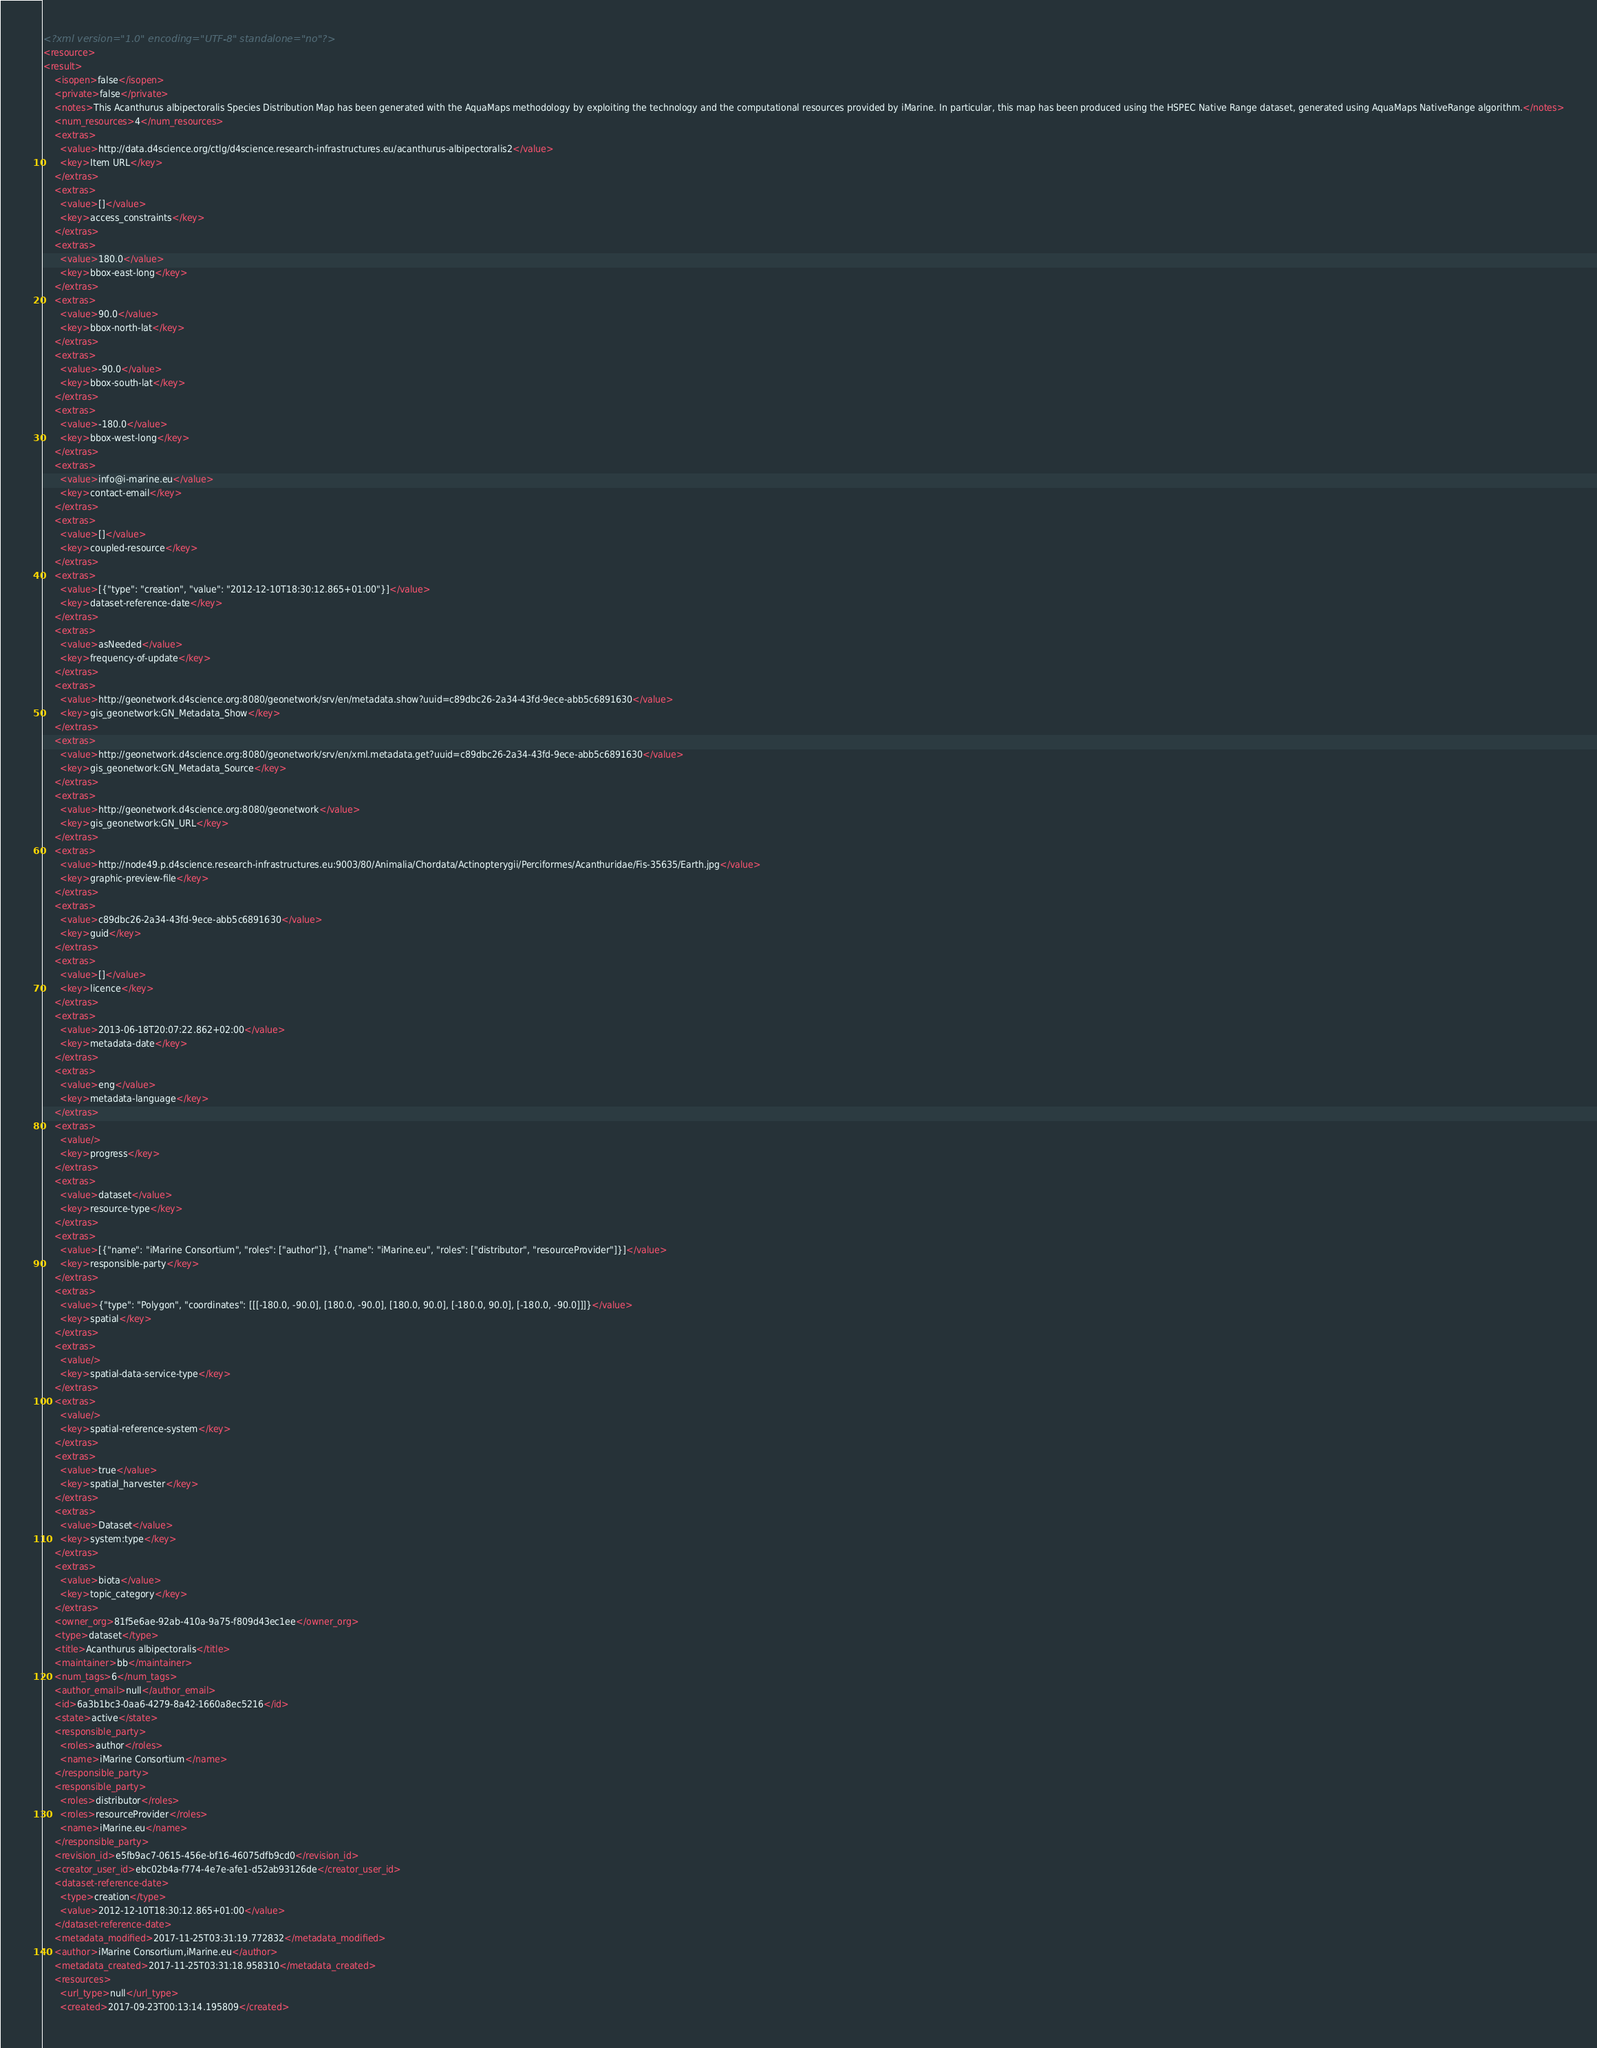<code> <loc_0><loc_0><loc_500><loc_500><_XML_><?xml version="1.0" encoding="UTF-8" standalone="no"?>
<resource>
<result>
    <isopen>false</isopen>
    <private>false</private>
    <notes>This Acanthurus albipectoralis Species Distribution Map has been generated with the AquaMaps methodology by exploiting the technology and the computational resources provided by iMarine. In particular, this map has been produced using the HSPEC Native Range dataset, generated using AquaMaps NativeRange algorithm.</notes>
    <num_resources>4</num_resources>
    <extras>
      <value>http://data.d4science.org/ctlg/d4science.research-infrastructures.eu/acanthurus-albipectoralis2</value>
      <key>Item URL</key>
    </extras>
    <extras>
      <value>[]</value>
      <key>access_constraints</key>
    </extras>
    <extras>
      <value>180.0</value>
      <key>bbox-east-long</key>
    </extras>
    <extras>
      <value>90.0</value>
      <key>bbox-north-lat</key>
    </extras>
    <extras>
      <value>-90.0</value>
      <key>bbox-south-lat</key>
    </extras>
    <extras>
      <value>-180.0</value>
      <key>bbox-west-long</key>
    </extras>
    <extras>
      <value>info@i-marine.eu</value>
      <key>contact-email</key>
    </extras>
    <extras>
      <value>[]</value>
      <key>coupled-resource</key>
    </extras>
    <extras>
      <value>[{"type": "creation", "value": "2012-12-10T18:30:12.865+01:00"}]</value>
      <key>dataset-reference-date</key>
    </extras>
    <extras>
      <value>asNeeded</value>
      <key>frequency-of-update</key>
    </extras>
    <extras>
      <value>http://geonetwork.d4science.org:8080/geonetwork/srv/en/metadata.show?uuid=c89dbc26-2a34-43fd-9ece-abb5c6891630</value>
      <key>gis_geonetwork:GN_Metadata_Show</key>
    </extras>
    <extras>
      <value>http://geonetwork.d4science.org:8080/geonetwork/srv/en/xml.metadata.get?uuid=c89dbc26-2a34-43fd-9ece-abb5c6891630</value>
      <key>gis_geonetwork:GN_Metadata_Source</key>
    </extras>
    <extras>
      <value>http://geonetwork.d4science.org:8080/geonetwork</value>
      <key>gis_geonetwork:GN_URL</key>
    </extras>
    <extras>
      <value>http://node49.p.d4science.research-infrastructures.eu:9003/80/Animalia/Chordata/Actinopterygii/Perciformes/Acanthuridae/Fis-35635/Earth.jpg</value>
      <key>graphic-preview-file</key>
    </extras>
    <extras>
      <value>c89dbc26-2a34-43fd-9ece-abb5c6891630</value>
      <key>guid</key>
    </extras>
    <extras>
      <value>[]</value>
      <key>licence</key>
    </extras>
    <extras>
      <value>2013-06-18T20:07:22.862+02:00</value>
      <key>metadata-date</key>
    </extras>
    <extras>
      <value>eng</value>
      <key>metadata-language</key>
    </extras>
    <extras>
      <value/>
      <key>progress</key>
    </extras>
    <extras>
      <value>dataset</value>
      <key>resource-type</key>
    </extras>
    <extras>
      <value>[{"name": "iMarine Consortium", "roles": ["author"]}, {"name": "iMarine.eu", "roles": ["distributor", "resourceProvider"]}]</value>
      <key>responsible-party</key>
    </extras>
    <extras>
      <value>{"type": "Polygon", "coordinates": [[[-180.0, -90.0], [180.0, -90.0], [180.0, 90.0], [-180.0, 90.0], [-180.0, -90.0]]]}</value>
      <key>spatial</key>
    </extras>
    <extras>
      <value/>
      <key>spatial-data-service-type</key>
    </extras>
    <extras>
      <value/>
      <key>spatial-reference-system</key>
    </extras>
    <extras>
      <value>true</value>
      <key>spatial_harvester</key>
    </extras>
    <extras>
      <value>Dataset</value>
      <key>system:type</key>
    </extras>
    <extras>
      <value>biota</value>
      <key>topic_category</key>
    </extras>
    <owner_org>81f5e6ae-92ab-410a-9a75-f809d43ec1ee</owner_org>
    <type>dataset</type>
    <title>Acanthurus albipectoralis</title>
    <maintainer>bb</maintainer>
    <num_tags>6</num_tags>
    <author_email>null</author_email>
    <id>6a3b1bc3-0aa6-4279-8a42-1660a8ec5216</id>
    <state>active</state>
    <responsible_party>
      <roles>author</roles>
      <name>iMarine Consortium</name>
    </responsible_party>
    <responsible_party>
      <roles>distributor</roles>
      <roles>resourceProvider</roles>
      <name>iMarine.eu</name>
    </responsible_party>
    <revision_id>e5fb9ac7-0615-456e-bf16-46075dfb9cd0</revision_id>
    <creator_user_id>ebc02b4a-f774-4e7e-afe1-d52ab93126de</creator_user_id>
    <dataset-reference-date>
      <type>creation</type>
      <value>2012-12-10T18:30:12.865+01:00</value>
    </dataset-reference-date>
    <metadata_modified>2017-11-25T03:31:19.772832</metadata_modified>
    <author>iMarine Consortium,iMarine.eu</author>
    <metadata_created>2017-11-25T03:31:18.958310</metadata_created>
    <resources>
      <url_type>null</url_type>
      <created>2017-09-23T00:13:14.195809</created></code> 